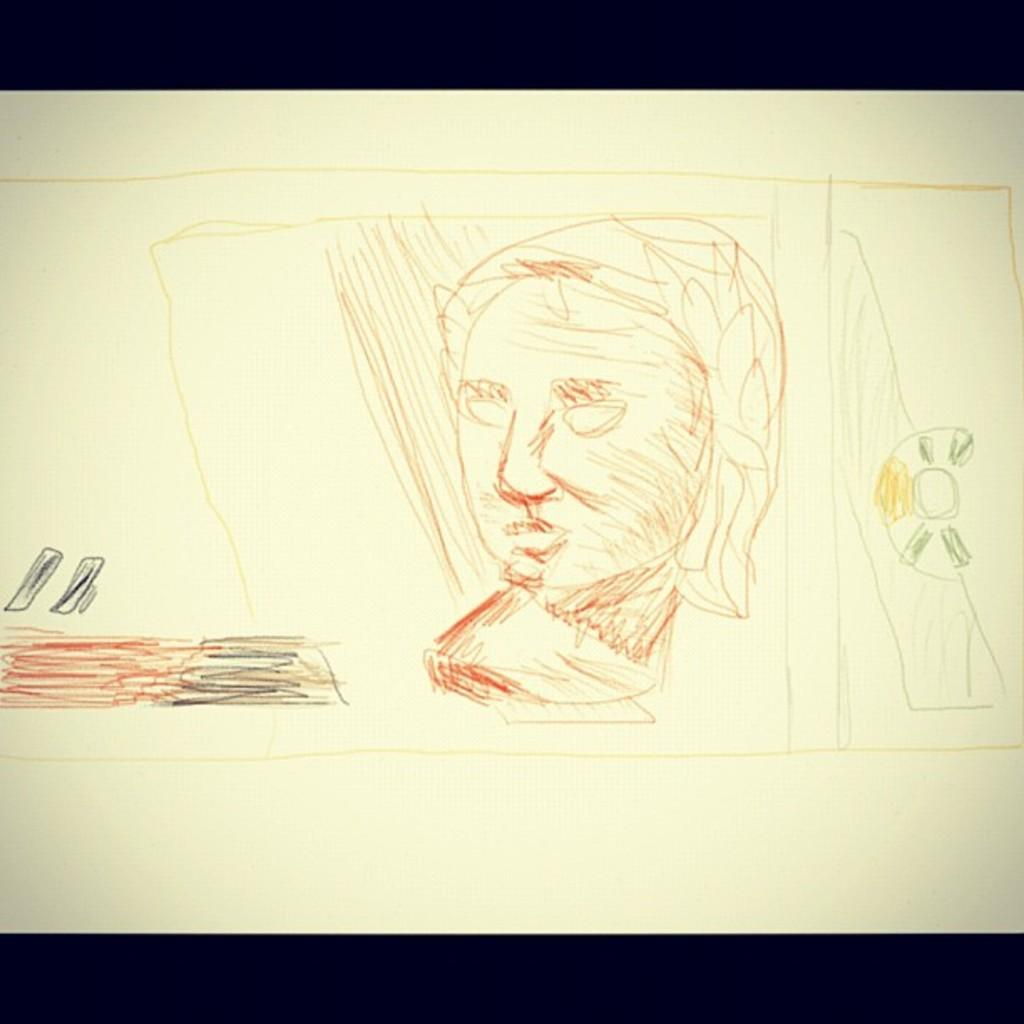What is the main subject of the image? There is an art piece in the image. What is the background or surface on which the art piece is placed? The art piece is on a white surface. What is the weight of the can in the image? There is no can present in the image, so it is not possible to determine its weight. 